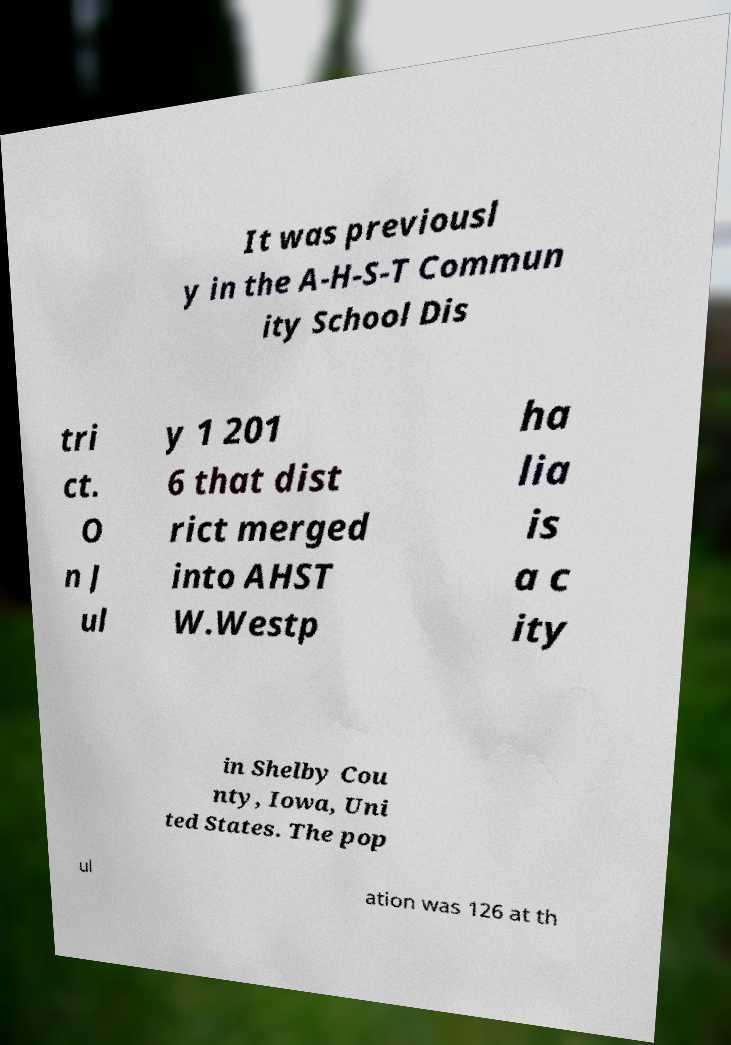There's text embedded in this image that I need extracted. Can you transcribe it verbatim? It was previousl y in the A-H-S-T Commun ity School Dis tri ct. O n J ul y 1 201 6 that dist rict merged into AHST W.Westp ha lia is a c ity in Shelby Cou nty, Iowa, Uni ted States. The pop ul ation was 126 at th 